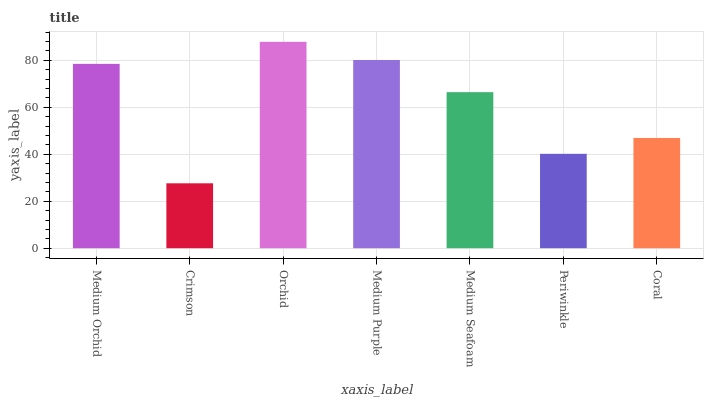Is Crimson the minimum?
Answer yes or no. Yes. Is Orchid the maximum?
Answer yes or no. Yes. Is Orchid the minimum?
Answer yes or no. No. Is Crimson the maximum?
Answer yes or no. No. Is Orchid greater than Crimson?
Answer yes or no. Yes. Is Crimson less than Orchid?
Answer yes or no. Yes. Is Crimson greater than Orchid?
Answer yes or no. No. Is Orchid less than Crimson?
Answer yes or no. No. Is Medium Seafoam the high median?
Answer yes or no. Yes. Is Medium Seafoam the low median?
Answer yes or no. Yes. Is Medium Orchid the high median?
Answer yes or no. No. Is Coral the low median?
Answer yes or no. No. 